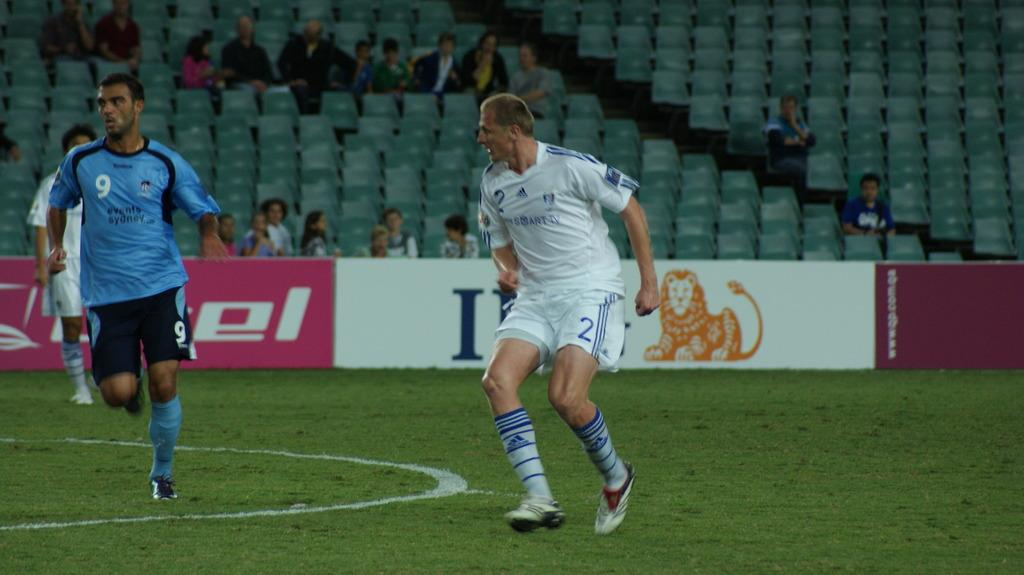<image>
Offer a succinct explanation of the picture presented. Two soccer players with one wearing a Sydney emblazoned blue jersey. 